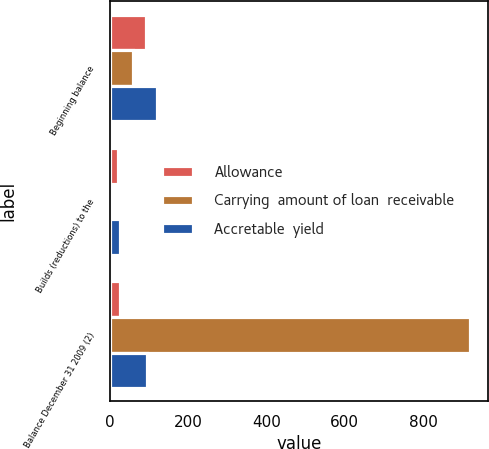Convert chart. <chart><loc_0><loc_0><loc_500><loc_500><stacked_bar_chart><ecel><fcel>Beginning balance<fcel>Builds (reductions) to the<fcel>Balance December 31 2009 (2)<nl><fcel>Allowance<fcel>92<fcel>21<fcel>27<nl><fcel>Carrying  amount of loan  receivable<fcel>59.5<fcel>1<fcel>920<nl><fcel>Accretable  yield<fcel>122<fcel>27<fcel>95<nl></chart> 